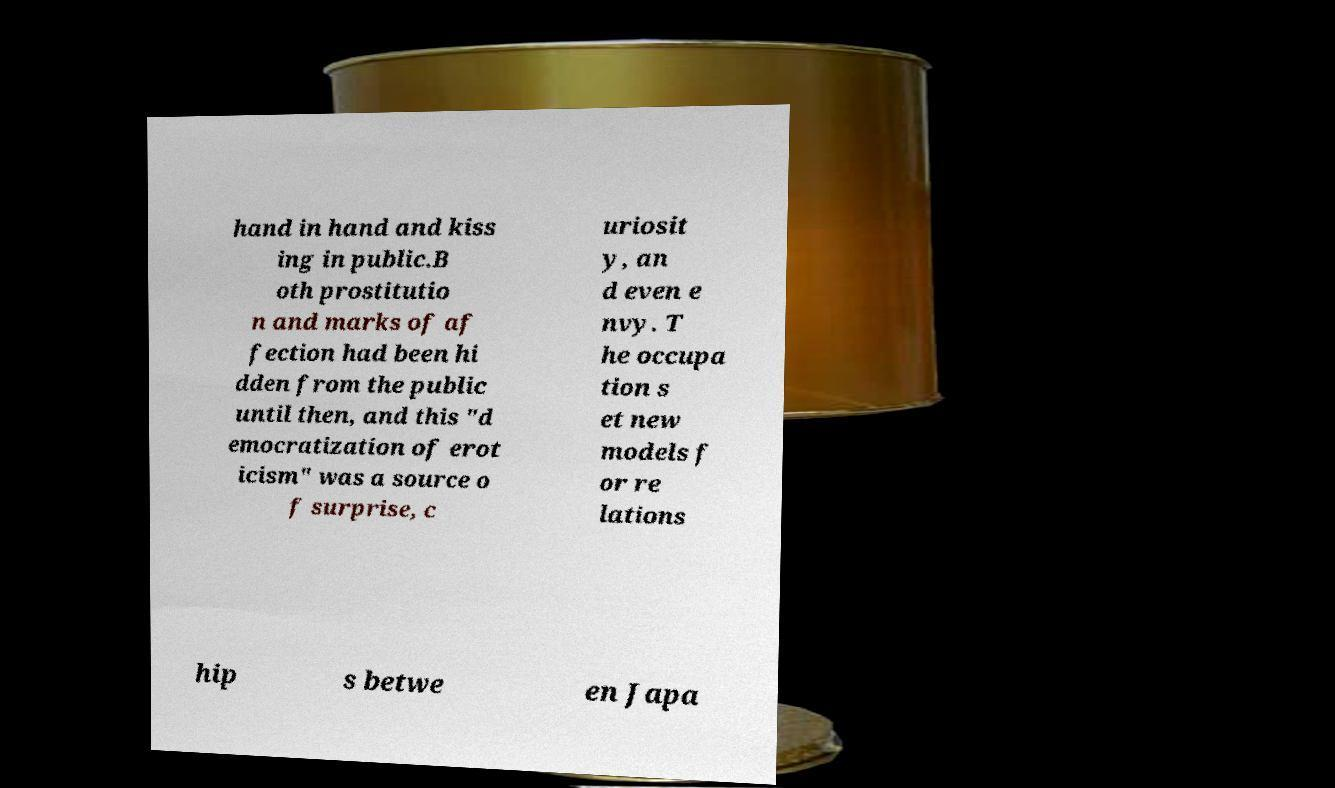For documentation purposes, I need the text within this image transcribed. Could you provide that? hand in hand and kiss ing in public.B oth prostitutio n and marks of af fection had been hi dden from the public until then, and this "d emocratization of erot icism" was a source o f surprise, c uriosit y, an d even e nvy. T he occupa tion s et new models f or re lations hip s betwe en Japa 